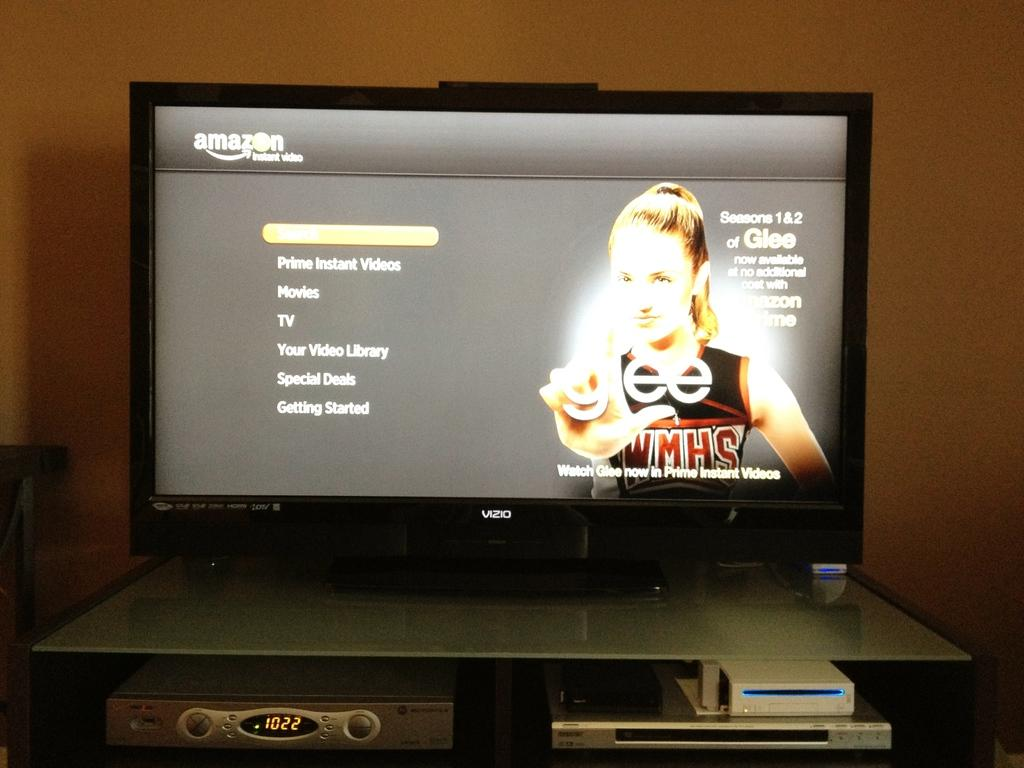<image>
Render a clear and concise summary of the photo. an amazon screen with the word tv on it 